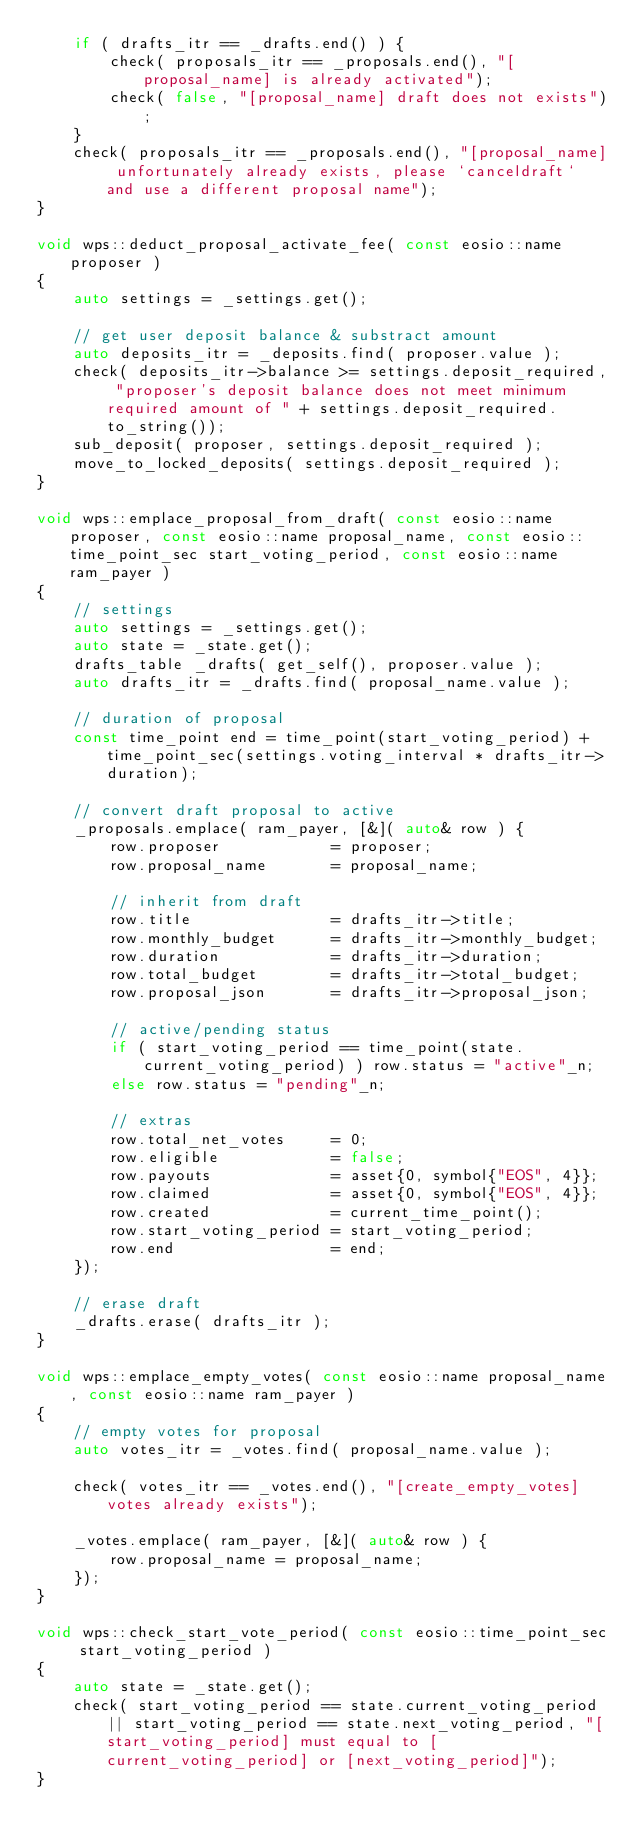<code> <loc_0><loc_0><loc_500><loc_500><_C++_>    if ( drafts_itr == _drafts.end() ) {
        check( proposals_itr == _proposals.end(), "[proposal_name] is already activated");
        check( false, "[proposal_name] draft does not exists");
    }
    check( proposals_itr == _proposals.end(), "[proposal_name] unfortunately already exists, please `canceldraft` and use a different proposal name");
}

void wps::deduct_proposal_activate_fee( const eosio::name proposer )
{
    auto settings = _settings.get();

    // get user deposit balance & substract amount
    auto deposits_itr = _deposits.find( proposer.value );
    check( deposits_itr->balance >= settings.deposit_required, "proposer's deposit balance does not meet minimum required amount of " + settings.deposit_required.to_string());
    sub_deposit( proposer, settings.deposit_required );
    move_to_locked_deposits( settings.deposit_required );
}

void wps::emplace_proposal_from_draft( const eosio::name proposer, const eosio::name proposal_name, const eosio::time_point_sec start_voting_period, const eosio::name ram_payer )
{
    // settings
    auto settings = _settings.get();
    auto state = _state.get();
    drafts_table _drafts( get_self(), proposer.value );
    auto drafts_itr = _drafts.find( proposal_name.value );

    // duration of proposal
    const time_point end = time_point(start_voting_period) + time_point_sec(settings.voting_interval * drafts_itr->duration);

    // convert draft proposal to active
    _proposals.emplace( ram_payer, [&]( auto& row ) {
        row.proposer            = proposer;
        row.proposal_name       = proposal_name;

        // inherit from draft
        row.title               = drafts_itr->title;
        row.monthly_budget      = drafts_itr->monthly_budget;
        row.duration            = drafts_itr->duration;
        row.total_budget        = drafts_itr->total_budget;
        row.proposal_json       = drafts_itr->proposal_json;

        // active/pending status
        if ( start_voting_period == time_point(state.current_voting_period) ) row.status = "active"_n;
        else row.status = "pending"_n;

        // extras
        row.total_net_votes     = 0;
        row.eligible            = false;
        row.payouts             = asset{0, symbol{"EOS", 4}};
        row.claimed             = asset{0, symbol{"EOS", 4}};
        row.created             = current_time_point();
        row.start_voting_period = start_voting_period;
        row.end                 = end;
    });

    // erase draft
    _drafts.erase( drafts_itr );
}

void wps::emplace_empty_votes( const eosio::name proposal_name, const eosio::name ram_payer )
{
    // empty votes for proposal
    auto votes_itr = _votes.find( proposal_name.value );

    check( votes_itr == _votes.end(), "[create_empty_votes] votes already exists");

    _votes.emplace( ram_payer, [&]( auto& row ) {
        row.proposal_name = proposal_name;
    });
}

void wps::check_start_vote_period( const eosio::time_point_sec start_voting_period )
{
    auto state = _state.get();
    check( start_voting_period == state.current_voting_period || start_voting_period == state.next_voting_period, "[start_voting_period] must equal to [current_voting_period] or [next_voting_period]");
}
</code> 